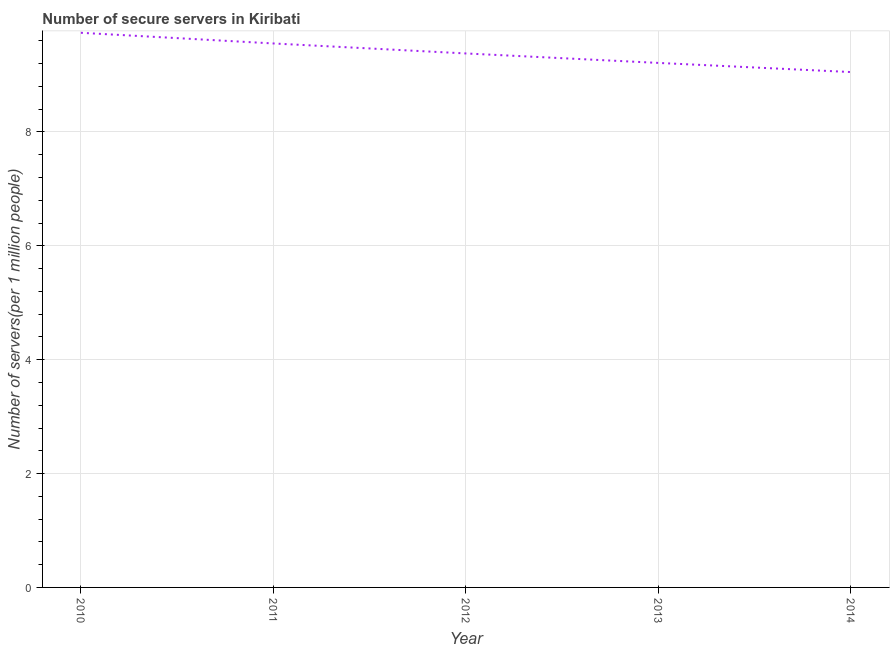What is the number of secure internet servers in 2013?
Offer a terse response. 9.21. Across all years, what is the maximum number of secure internet servers?
Your answer should be compact. 9.74. Across all years, what is the minimum number of secure internet servers?
Your answer should be compact. 9.05. In which year was the number of secure internet servers maximum?
Keep it short and to the point. 2010. What is the sum of the number of secure internet servers?
Provide a short and direct response. 46.94. What is the difference between the number of secure internet servers in 2012 and 2014?
Offer a very short reply. 0.33. What is the average number of secure internet servers per year?
Make the answer very short. 9.39. What is the median number of secure internet servers?
Your answer should be compact. 9.38. What is the ratio of the number of secure internet servers in 2012 to that in 2014?
Your answer should be very brief. 1.04. Is the number of secure internet servers in 2012 less than that in 2014?
Ensure brevity in your answer.  No. Is the difference between the number of secure internet servers in 2011 and 2013 greater than the difference between any two years?
Your response must be concise. No. What is the difference between the highest and the second highest number of secure internet servers?
Give a very brief answer. 0.19. What is the difference between the highest and the lowest number of secure internet servers?
Offer a terse response. 0.69. How many lines are there?
Give a very brief answer. 1. How many years are there in the graph?
Your response must be concise. 5. Does the graph contain any zero values?
Give a very brief answer. No. What is the title of the graph?
Offer a very short reply. Number of secure servers in Kiribati. What is the label or title of the X-axis?
Provide a succinct answer. Year. What is the label or title of the Y-axis?
Provide a succinct answer. Number of servers(per 1 million people). What is the Number of servers(per 1 million people) in 2010?
Your answer should be compact. 9.74. What is the Number of servers(per 1 million people) of 2011?
Ensure brevity in your answer.  9.55. What is the Number of servers(per 1 million people) in 2012?
Provide a short and direct response. 9.38. What is the Number of servers(per 1 million people) in 2013?
Your response must be concise. 9.21. What is the Number of servers(per 1 million people) of 2014?
Provide a short and direct response. 9.05. What is the difference between the Number of servers(per 1 million people) in 2010 and 2011?
Keep it short and to the point. 0.19. What is the difference between the Number of servers(per 1 million people) in 2010 and 2012?
Your answer should be compact. 0.36. What is the difference between the Number of servers(per 1 million people) in 2010 and 2013?
Provide a succinct answer. 0.53. What is the difference between the Number of servers(per 1 million people) in 2010 and 2014?
Ensure brevity in your answer.  0.69. What is the difference between the Number of servers(per 1 million people) in 2011 and 2012?
Make the answer very short. 0.18. What is the difference between the Number of servers(per 1 million people) in 2011 and 2013?
Your answer should be compact. 0.34. What is the difference between the Number of servers(per 1 million people) in 2011 and 2014?
Your answer should be very brief. 0.5. What is the difference between the Number of servers(per 1 million people) in 2012 and 2013?
Ensure brevity in your answer.  0.17. What is the difference between the Number of servers(per 1 million people) in 2012 and 2014?
Provide a succinct answer. 0.33. What is the difference between the Number of servers(per 1 million people) in 2013 and 2014?
Your response must be concise. 0.16. What is the ratio of the Number of servers(per 1 million people) in 2010 to that in 2011?
Your response must be concise. 1.02. What is the ratio of the Number of servers(per 1 million people) in 2010 to that in 2012?
Offer a terse response. 1.04. What is the ratio of the Number of servers(per 1 million people) in 2010 to that in 2013?
Provide a short and direct response. 1.06. What is the ratio of the Number of servers(per 1 million people) in 2010 to that in 2014?
Your answer should be compact. 1.08. What is the ratio of the Number of servers(per 1 million people) in 2011 to that in 2012?
Keep it short and to the point. 1.02. What is the ratio of the Number of servers(per 1 million people) in 2011 to that in 2013?
Give a very brief answer. 1.04. What is the ratio of the Number of servers(per 1 million people) in 2011 to that in 2014?
Ensure brevity in your answer.  1.05. What is the ratio of the Number of servers(per 1 million people) in 2012 to that in 2014?
Your answer should be compact. 1.04. 